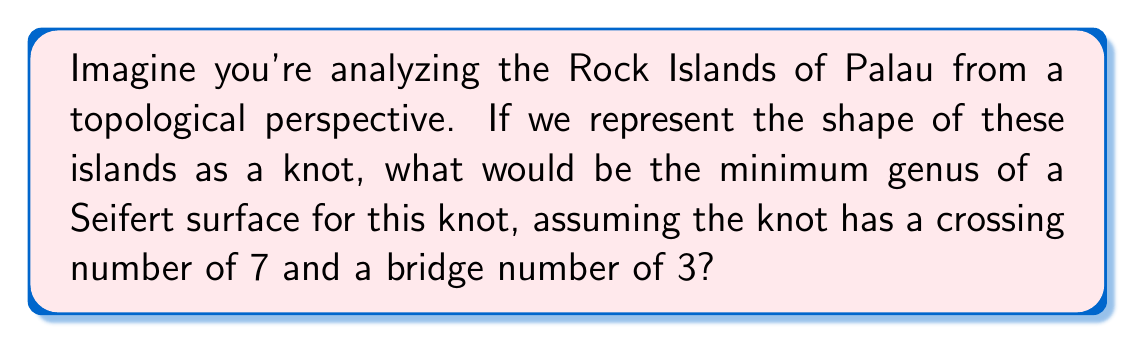Help me with this question. Let's approach this step-by-step:

1) In knot theory, the genus of a knot is defined as the minimum genus of any Seifert surface for the knot.

2) There's a relationship between the genus (g), crossing number (c), and bridge number (b) of a knot. This relationship is given by the inequality:

   $$2g \leq c - 2b + 2$$

3) We're given that the crossing number (c) is 7 and the bridge number (b) is 3.

4) Let's substitute these values into the inequality:

   $$2g \leq 7 - 2(3) + 2$$

5) Simplify:
   $$2g \leq 7 - 6 + 2 = 3$$

6) Divide both sides by 2:
   $$g \leq \frac{3}{2}$$

7) Since the genus must be a non-negative integer, the minimum value that satisfies this inequality is 1.

8) Therefore, the minimum genus of a Seifert surface for this knot is 1.

This result suggests that the Rock Islands of Palau, when represented as a knot, have a topological complexity equivalent to a torus knot.
Answer: 1 